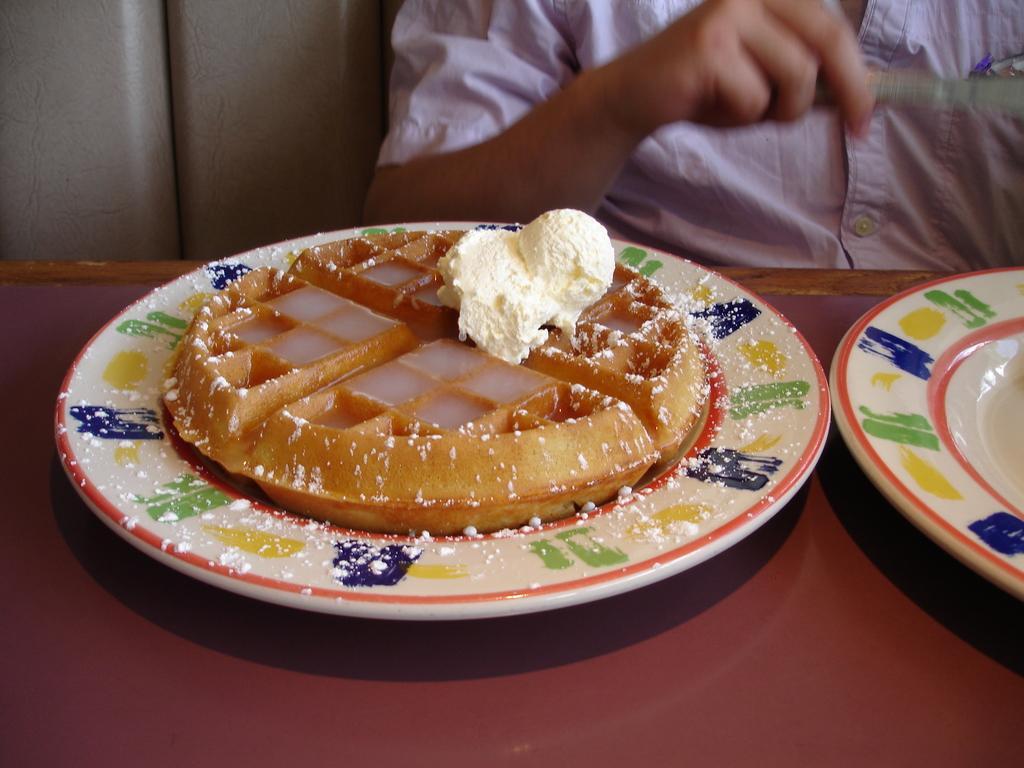Describe this image in one or two sentences. In this picture we can see two plates on the platform, food items on a plate, person and some objects. 